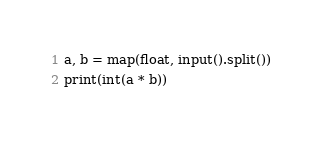Convert code to text. <code><loc_0><loc_0><loc_500><loc_500><_Python_>a, b = map(float, input().split())
print(int(a * b))</code> 